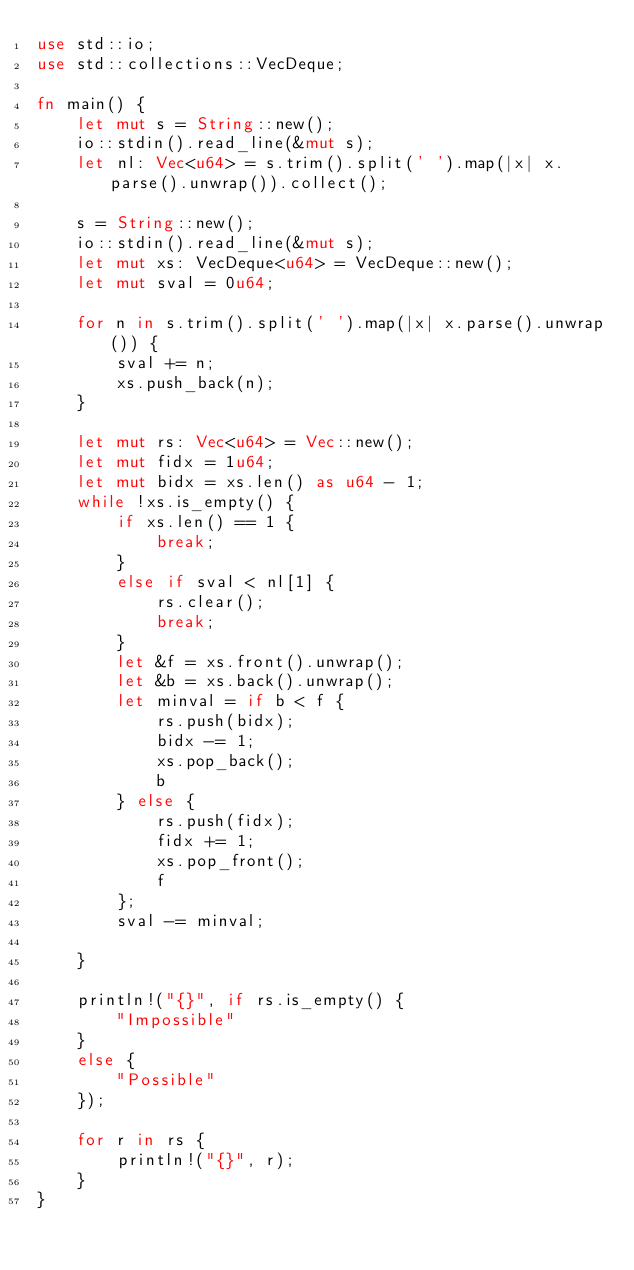<code> <loc_0><loc_0><loc_500><loc_500><_Rust_>use std::io;
use std::collections::VecDeque;

fn main() {
    let mut s = String::new();
    io::stdin().read_line(&mut s);
    let nl: Vec<u64> = s.trim().split(' ').map(|x| x.parse().unwrap()).collect();

    s = String::new();
    io::stdin().read_line(&mut s);
    let mut xs: VecDeque<u64> = VecDeque::new();
    let mut sval = 0u64;

    for n in s.trim().split(' ').map(|x| x.parse().unwrap()) {
        sval += n;
        xs.push_back(n);
    }

    let mut rs: Vec<u64> = Vec::new();
    let mut fidx = 1u64;
    let mut bidx = xs.len() as u64 - 1;
    while !xs.is_empty() {
        if xs.len() == 1 {
            break;
        }
        else if sval < nl[1] {
            rs.clear();
            break;
        }
        let &f = xs.front().unwrap();
        let &b = xs.back().unwrap();
        let minval = if b < f {
            rs.push(bidx);
            bidx -= 1;
            xs.pop_back();
            b
        } else {
            rs.push(fidx);
            fidx += 1;
            xs.pop_front();
            f
        };
        sval -= minval;

    }

    println!("{}", if rs.is_empty() {
        "Impossible"
    }
    else {
        "Possible"
    });

    for r in rs {
        println!("{}", r);
    }
}
</code> 